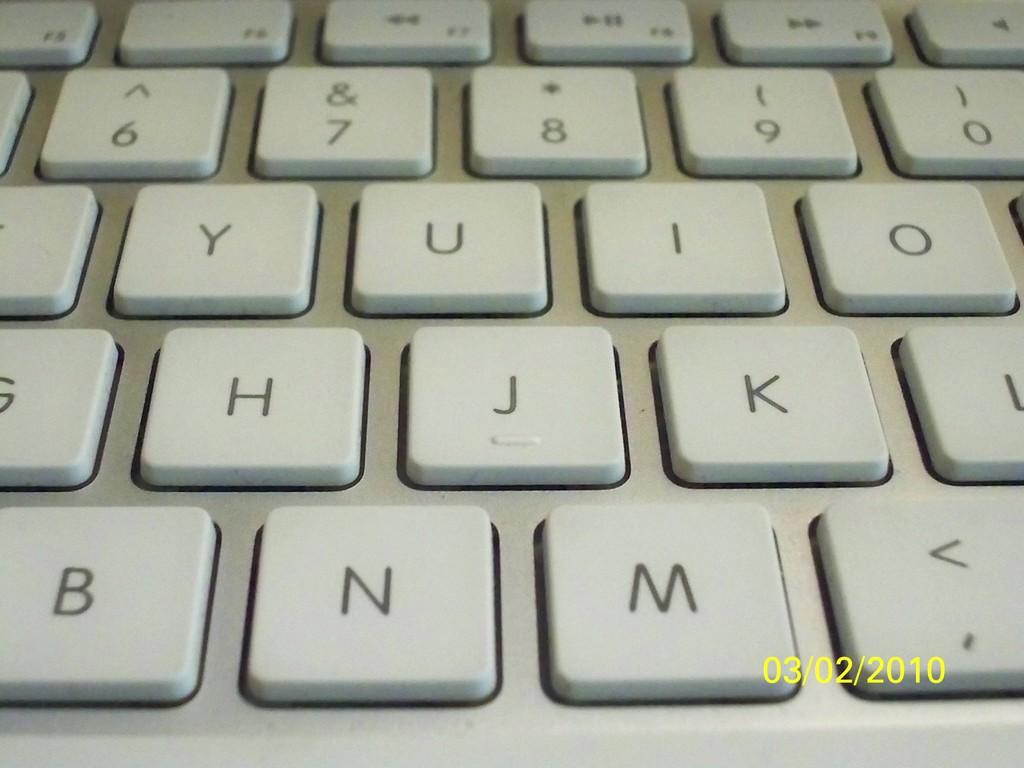When was this picture taken?
Offer a very short reply. 03/02/2010. What letter key can you see on the very bottom left?
Your answer should be very brief. B. 